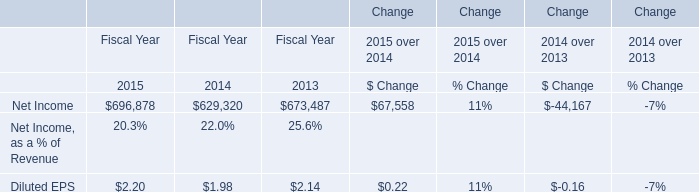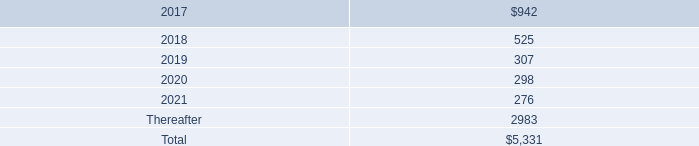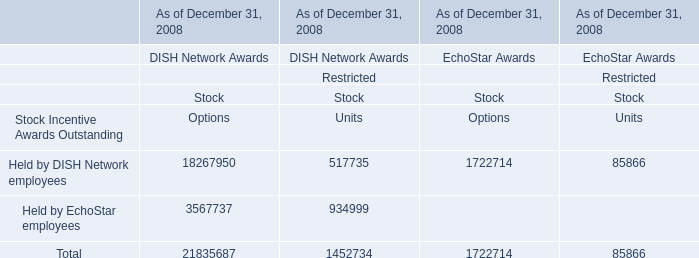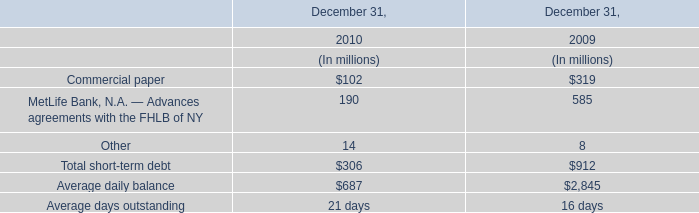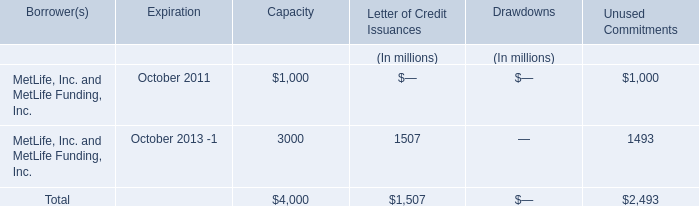What is the ratio of Other to the total in 2010? 
Computations: (14 / (306 + 687))
Answer: 0.0141. 